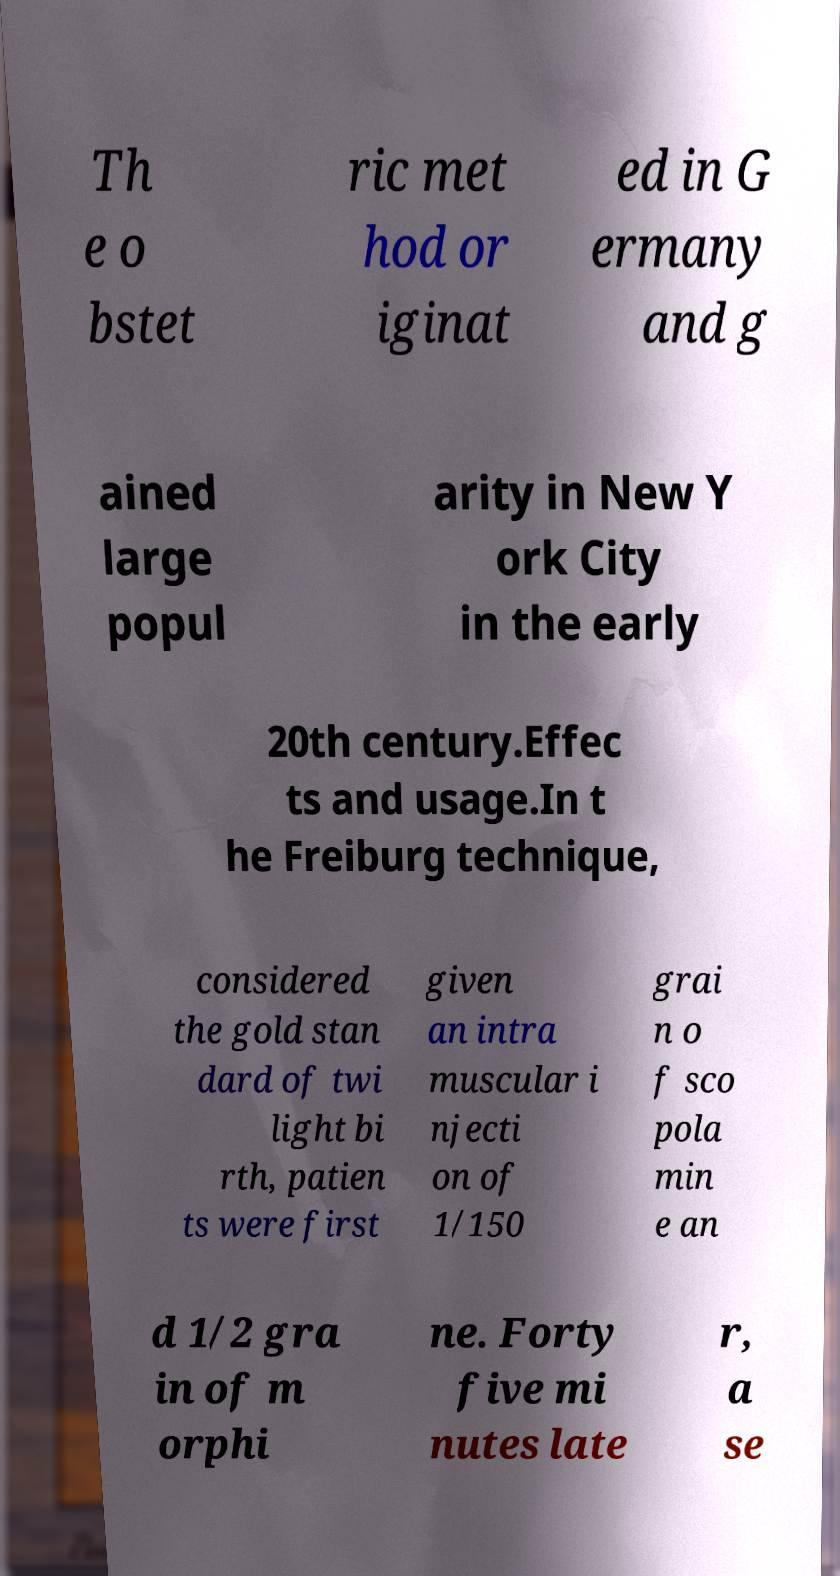Can you read and provide the text displayed in the image?This photo seems to have some interesting text. Can you extract and type it out for me? Th e o bstet ric met hod or iginat ed in G ermany and g ained large popul arity in New Y ork City in the early 20th century.Effec ts and usage.In t he Freiburg technique, considered the gold stan dard of twi light bi rth, patien ts were first given an intra muscular i njecti on of 1/150 grai n o f sco pola min e an d 1/2 gra in of m orphi ne. Forty five mi nutes late r, a se 